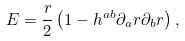<formula> <loc_0><loc_0><loc_500><loc_500>E = \frac { r } { 2 } \left ( 1 - h ^ { a b } \partial _ { a } r \partial _ { b } r \right ) ,</formula> 